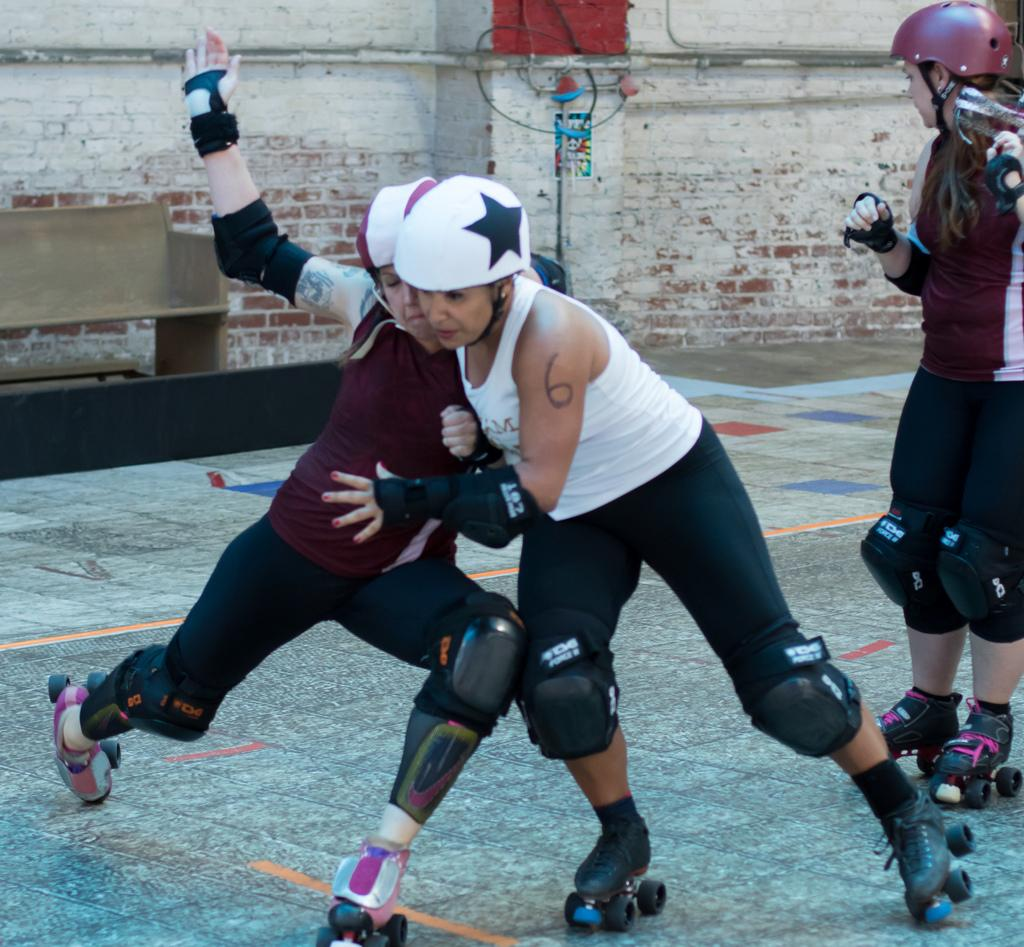What type of footwear and protective gear are the people wearing in the image? The people are wearing skating shoes and helmets in the image. What are the people doing in the image? The people are in motion, which suggests they are skating. What can be seen in the background of the image? There is a wall, a bench, a poster, and a cable in the background. Can you see an owl perched on the cable in the background? There is no owl present in the image; it only features people skating and the mentioned background elements. 